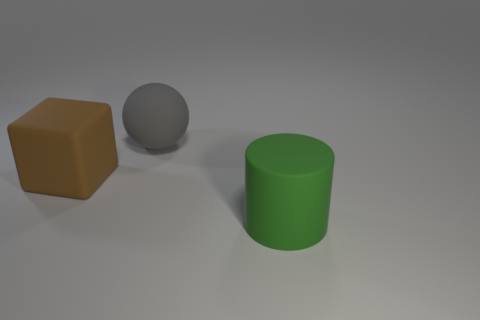There is a object that is in front of the large brown matte object; what is its size?
Ensure brevity in your answer.  Large. Is the number of big purple rubber spheres less than the number of cylinders?
Provide a short and direct response. Yes. What is the shape of the big thing to the right of the thing behind the big matte thing that is to the left of the big gray thing?
Provide a short and direct response. Cylinder. How many green cubes are the same material as the gray thing?
Offer a terse response. 0. There is a matte thing behind the large brown block; what number of rubber objects are to the right of it?
Your answer should be very brief. 1. There is a rubber object that is to the left of the sphere; is it the same color as the big rubber thing right of the gray thing?
Make the answer very short. No. What is the shape of the thing that is both in front of the big gray rubber ball and behind the green rubber cylinder?
Give a very brief answer. Cube. What shape is the brown rubber thing that is the same size as the matte cylinder?
Keep it short and to the point. Cube. What material is the large green object?
Your response must be concise. Rubber. How many rubber things are either purple spheres or brown cubes?
Your response must be concise. 1. 